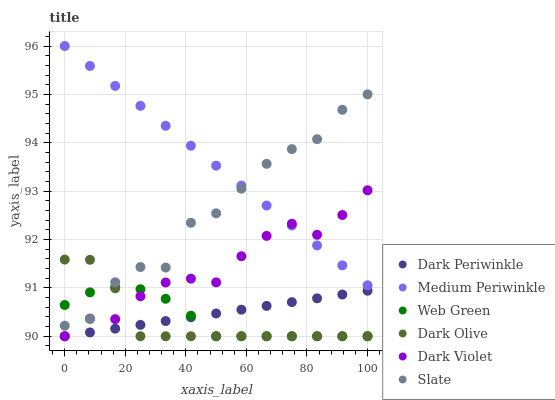Does Dark Olive have the minimum area under the curve?
Answer yes or no. Yes. Does Medium Periwinkle have the maximum area under the curve?
Answer yes or no. Yes. Does Medium Periwinkle have the minimum area under the curve?
Answer yes or no. No. Does Dark Olive have the maximum area under the curve?
Answer yes or no. No. Is Dark Periwinkle the smoothest?
Answer yes or no. Yes. Is Slate the roughest?
Answer yes or no. Yes. Is Dark Olive the smoothest?
Answer yes or no. No. Is Dark Olive the roughest?
Answer yes or no. No. Does Dark Olive have the lowest value?
Answer yes or no. Yes. Does Medium Periwinkle have the lowest value?
Answer yes or no. No. Does Medium Periwinkle have the highest value?
Answer yes or no. Yes. Does Dark Olive have the highest value?
Answer yes or no. No. Is Web Green less than Medium Periwinkle?
Answer yes or no. Yes. Is Medium Periwinkle greater than Web Green?
Answer yes or no. Yes. Does Dark Olive intersect Dark Violet?
Answer yes or no. Yes. Is Dark Olive less than Dark Violet?
Answer yes or no. No. Is Dark Olive greater than Dark Violet?
Answer yes or no. No. Does Web Green intersect Medium Periwinkle?
Answer yes or no. No. 